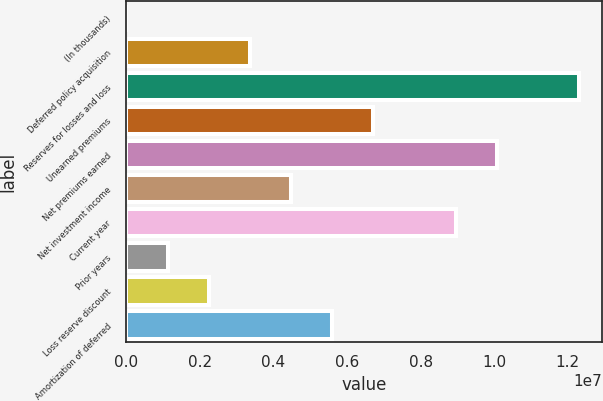Convert chart. <chart><loc_0><loc_0><loc_500><loc_500><bar_chart><fcel>(In thousands)<fcel>Deferred policy acquisition<fcel>Reserves for losses and loss<fcel>Unearned premiums<fcel>Net premiums earned<fcel>Net investment income<fcel>Current year<fcel>Prior years<fcel>Loss reserve discount<fcel>Amortization of deferred<nl><fcel>2016<fcel>3.36057e+06<fcel>1.23167e+07<fcel>6.71912e+06<fcel>1.00777e+07<fcel>4.48009e+06<fcel>8.95816e+06<fcel>1.12153e+06<fcel>2.24105e+06<fcel>5.59961e+06<nl></chart> 